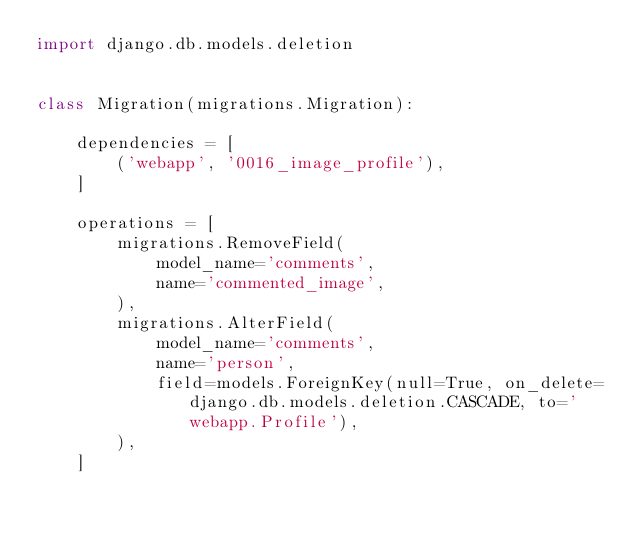<code> <loc_0><loc_0><loc_500><loc_500><_Python_>import django.db.models.deletion


class Migration(migrations.Migration):

    dependencies = [
        ('webapp', '0016_image_profile'),
    ]

    operations = [
        migrations.RemoveField(
            model_name='comments',
            name='commented_image',
        ),
        migrations.AlterField(
            model_name='comments',
            name='person',
            field=models.ForeignKey(null=True, on_delete=django.db.models.deletion.CASCADE, to='webapp.Profile'),
        ),
    ]
</code> 